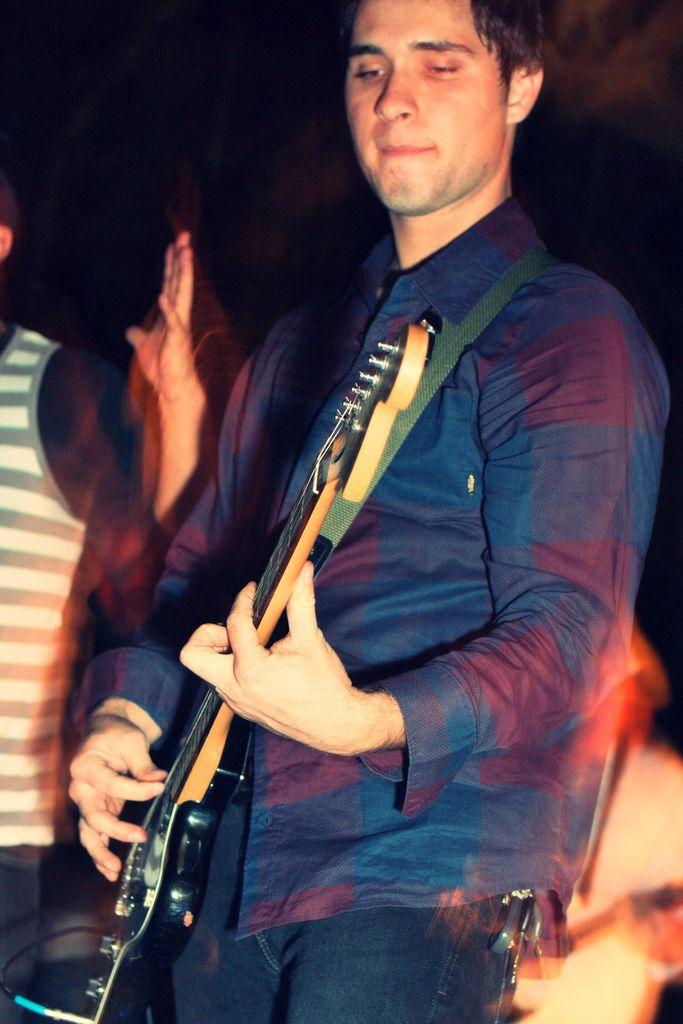What is the man in the image doing? The man is standing and playing a guitar. Can you describe the other person in the image? The other person is standing in the background. What is the man holding in the image? The man is holding a guitar. How many people are present in the image? There are two people in the image. What type of vacation is the man planning based on the image? There is no indication of a vacation in the image; it simply shows a man playing a guitar and another person standing in the background. How does the image promote peace? The image does not specifically promote peace; it is a snapshot of a man playing a guitar and another person standing nearby. 